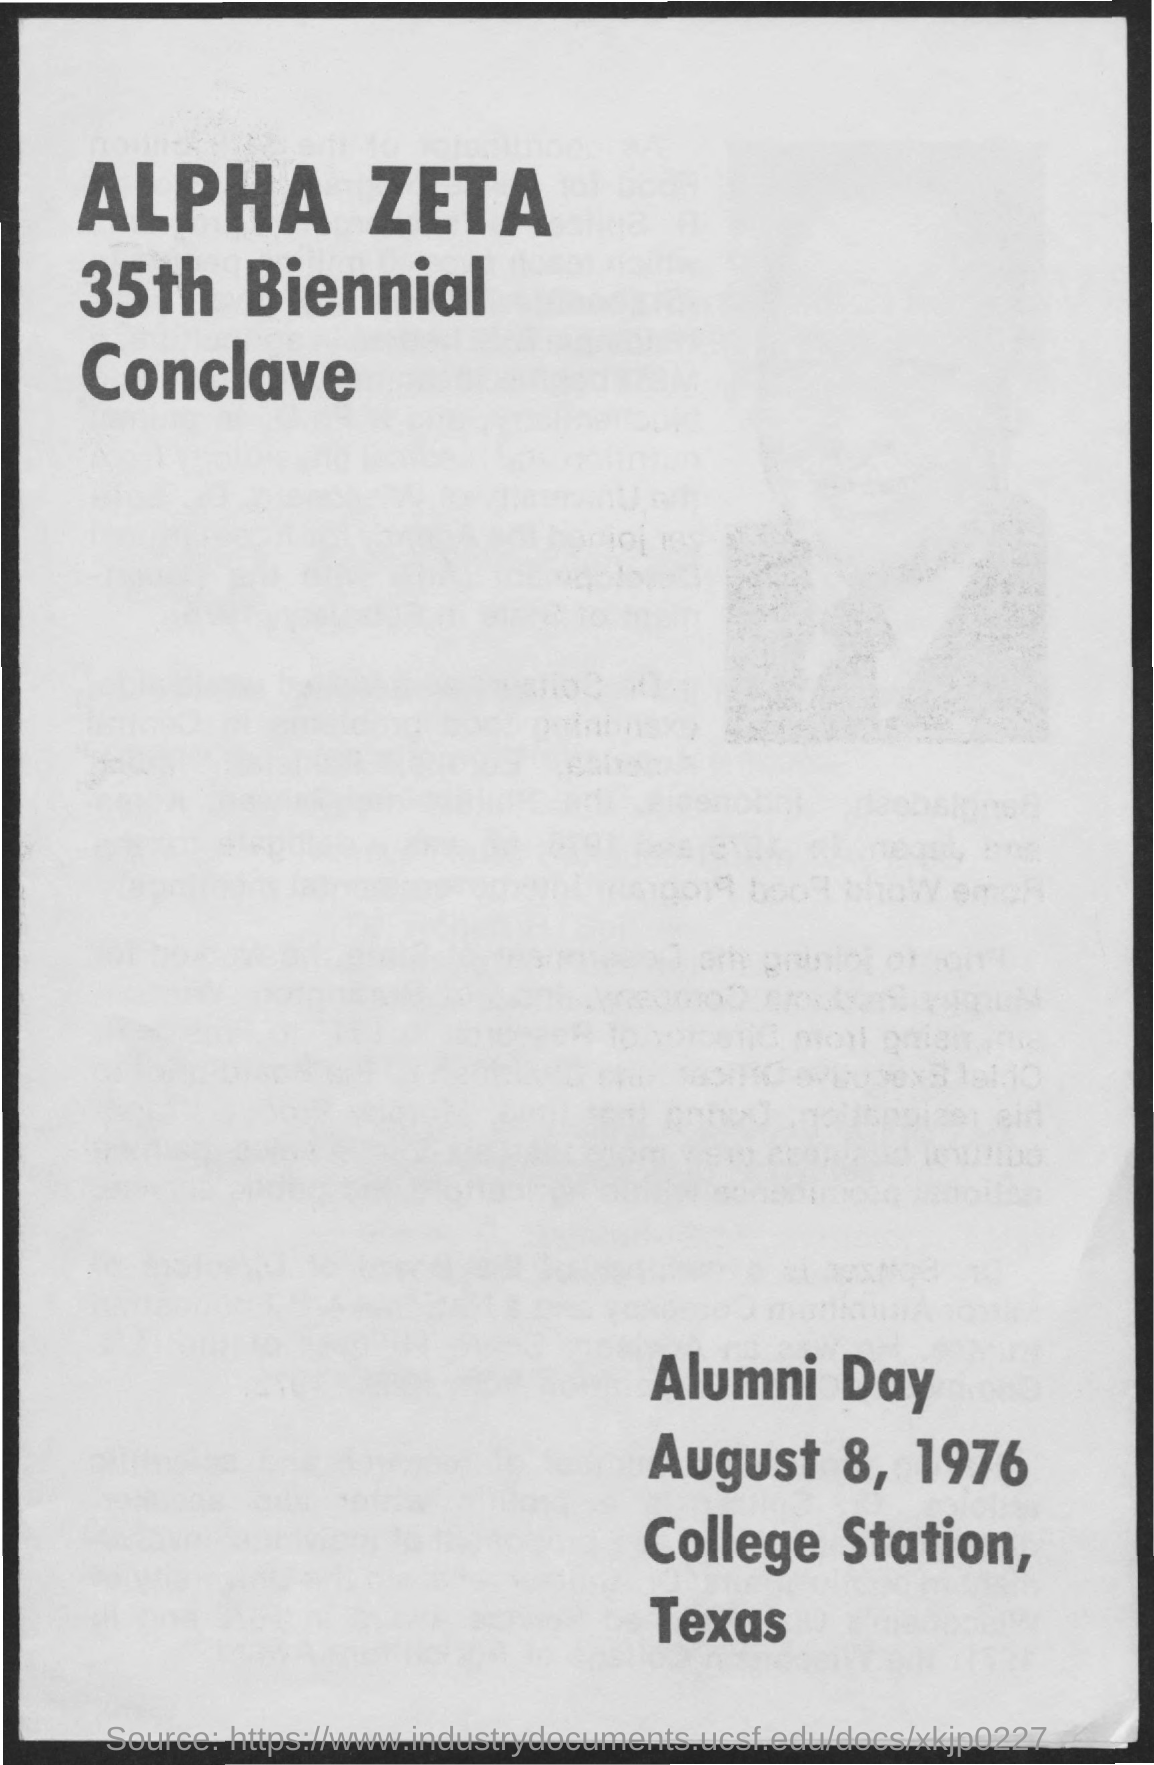What is name of the conclave?
Provide a short and direct response. Alpha zeta 35th biennial conclave. When is the alumni day?
Make the answer very short. August 8, 1976. Where is alumni day is held at?
Offer a terse response. College Station, Texas. In what year does this Alpha Zeta 35th Biennial Conclave held on?
Provide a succinct answer. 1976. Which month of the year is mentioned in the page?
Your answer should be compact. August. 